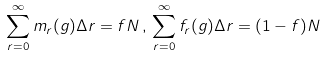Convert formula to latex. <formula><loc_0><loc_0><loc_500><loc_500>\sum _ { r = 0 } ^ { \infty } m _ { r } ( g ) \Delta r = f N \, , \, \sum _ { r = 0 } ^ { \infty } f _ { r } ( g ) \Delta r = ( 1 - f ) N</formula> 